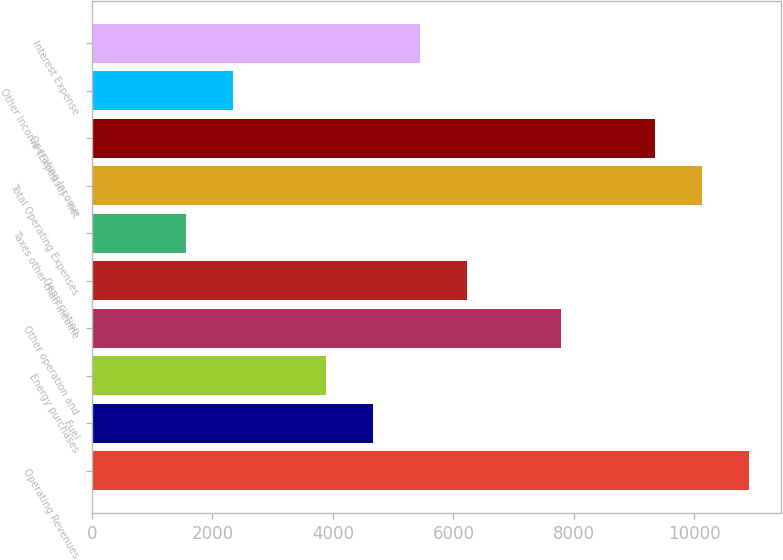<chart> <loc_0><loc_0><loc_500><loc_500><bar_chart><fcel>Operating Revenues<fcel>Fuel<fcel>Energy purchases<fcel>Other operation and<fcel>Depreciation<fcel>Taxes other than income<fcel>Total Operating Expenses<fcel>Operating Income<fcel>Other Income (Expense) - net<fcel>Interest Expense<nl><fcel>10897.9<fcel>4672.02<fcel>3893.78<fcel>7784.98<fcel>6228.5<fcel>1559.06<fcel>10119.7<fcel>9341.46<fcel>2337.3<fcel>5450.26<nl></chart> 